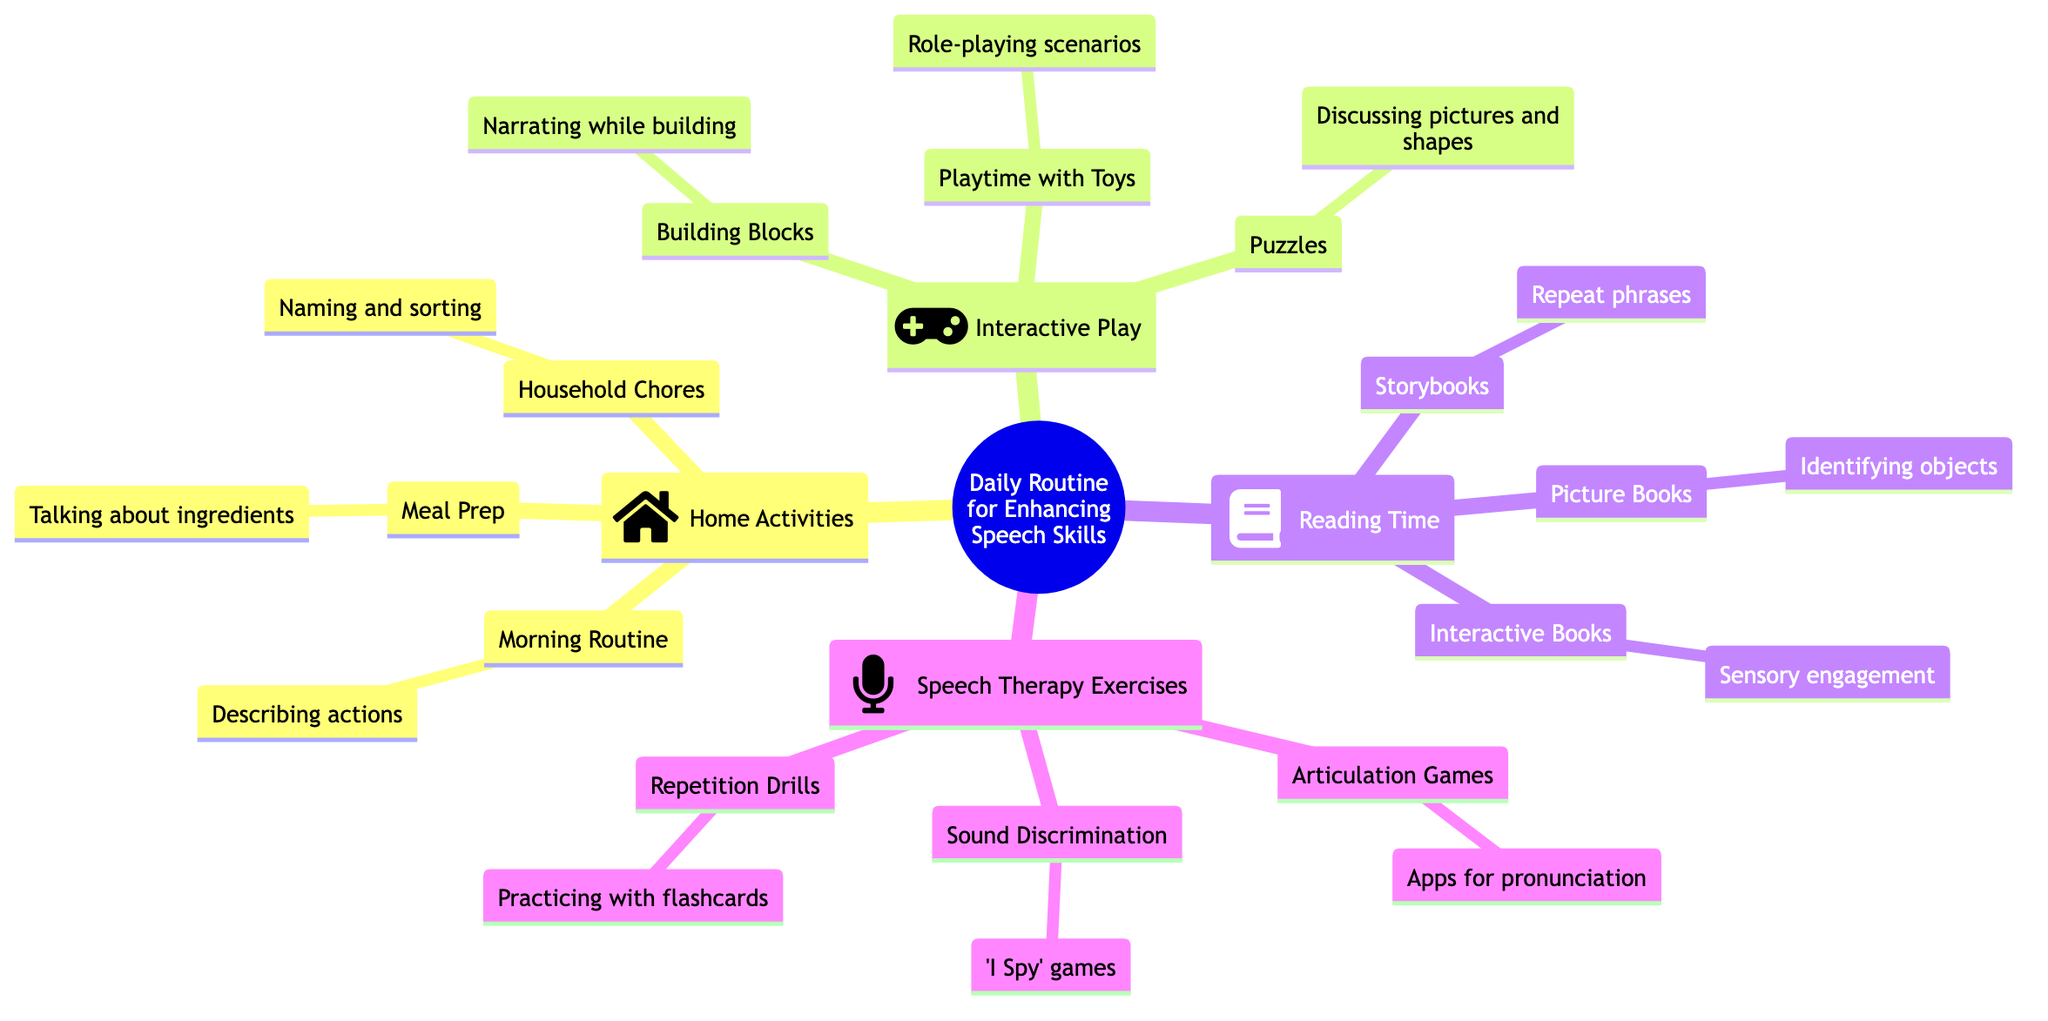What are the four main sections in the mind map? The sections include Home Activities, Interactive Play, Reading Time, and Speech Therapy Exercises. Each section is distinct and can be found under the main node "Daily Routine for Enhancing Speech Skills."
Answer: Home Activities, Interactive Play, Reading Time, Speech Therapy Exercises What type of activities are included under Home Activities? The activities listed under Home Activities include Morning Routine, Household Chores, and Meal Prep. These activities focus on enhancing speech through daily tasks and engagement.
Answer: Morning Routine, Household Chores, Meal Prep How does the Reading Time section enhance speech skills? The Reading Time section enhances speech skills by incorporating Storybooks, Picture Books, and Interactive Books, which emphasize repetition, object identification, and sensory engagement, respectively.
Answer: Storybooks, Picture Books, Interactive Books What game is mentioned under Speech Therapy Exercises for pronunciation practice? The game mentioned is "Articulation Games," which uses apps like 'Speech Blubs' for engaging in pronunciation exercises.
Answer: Articulation Games How many types of interactive plays are suggested in the mind map? There are three types of interactive plays: Playtime with Toys, Building Blocks, and Puzzles. Each activity is designed to foster speech development through creative play.
Answer: Three What is the objective of using Puzzles in interactive play? The objective of using Puzzles is to discuss the pictures and shapes, promoting language development through conversation and descriptions of the puzzle pieces.
Answer: Discussing pictures and shapes What is the primary focus of the Repetition Drills exercise? The primary focus of the Repetition Drills exercise is practicing words with flashcards, which helps reinforce vocabulary through repetition.
Answer: Practicing words with flashcards What activity involves role-playing scenarios? The activity that involves role-playing scenarios is "Playtime with Toys," where children can use dolls or action figures to act out different situations, enhancing imaginative play and language use.
Answer: Role-playing scenarios 